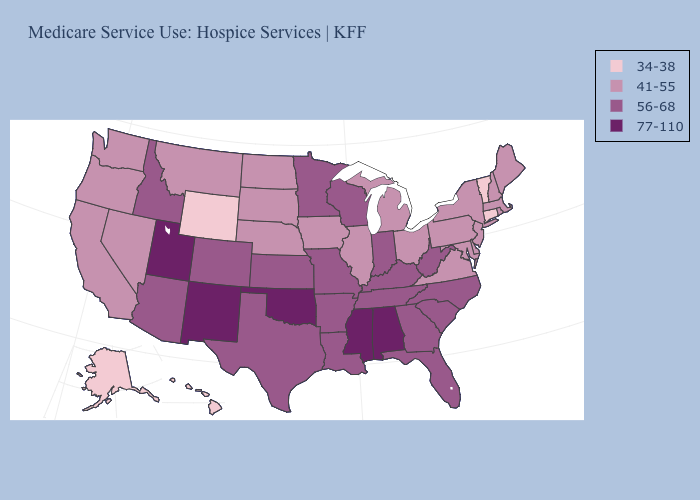Does Maine have a higher value than South Carolina?
Short answer required. No. What is the value of Nebraska?
Answer briefly. 41-55. Does Vermont have the lowest value in the Northeast?
Short answer required. Yes. Among the states that border Connecticut , which have the lowest value?
Quick response, please. Massachusetts, New York, Rhode Island. Among the states that border Michigan , which have the highest value?
Write a very short answer. Indiana, Wisconsin. What is the value of Minnesota?
Concise answer only. 56-68. Does the first symbol in the legend represent the smallest category?
Keep it brief. Yes. Name the states that have a value in the range 77-110?
Keep it brief. Alabama, Mississippi, New Mexico, Oklahoma, Utah. Does the map have missing data?
Quick response, please. No. What is the highest value in the South ?
Concise answer only. 77-110. Does Arizona have the lowest value in the USA?
Be succinct. No. Name the states that have a value in the range 41-55?
Give a very brief answer. California, Delaware, Illinois, Iowa, Maine, Maryland, Massachusetts, Michigan, Montana, Nebraska, Nevada, New Hampshire, New Jersey, New York, North Dakota, Ohio, Oregon, Pennsylvania, Rhode Island, South Dakota, Virginia, Washington. What is the value of Utah?
Short answer required. 77-110. What is the highest value in the Northeast ?
Give a very brief answer. 41-55. What is the highest value in states that border Rhode Island?
Short answer required. 41-55. 